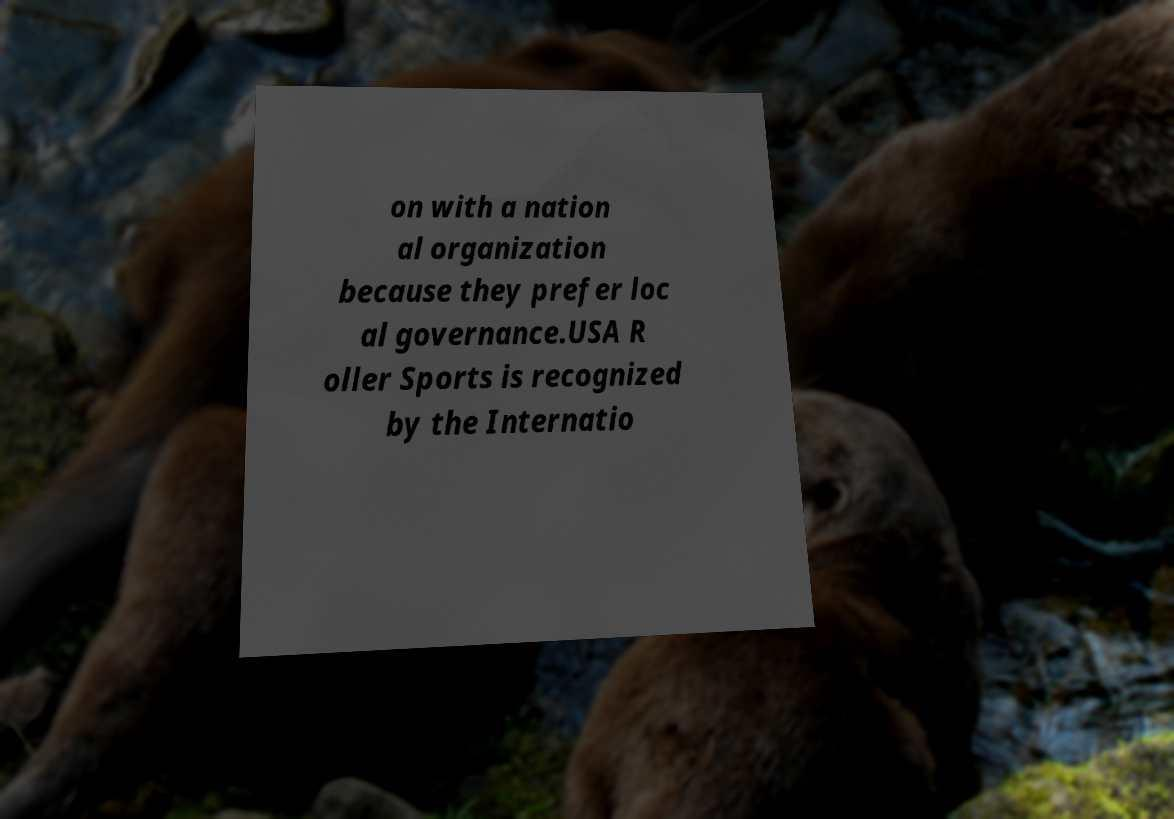Could you assist in decoding the text presented in this image and type it out clearly? on with a nation al organization because they prefer loc al governance.USA R oller Sports is recognized by the Internatio 